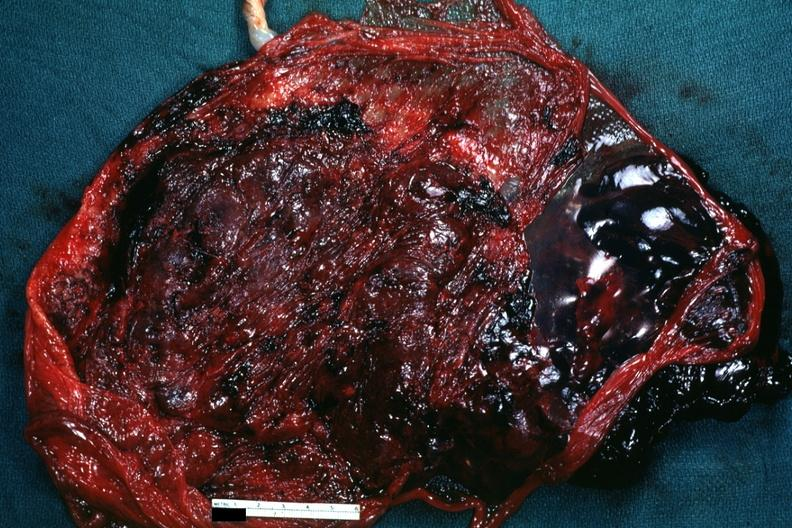how does this image show maternal surface?
Answer the question using a single word or phrase. With blood clot 